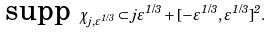<formula> <loc_0><loc_0><loc_500><loc_500>\text {supp } \chi _ { j , \varepsilon ^ { 1 / 3 } } \subset j \varepsilon ^ { 1 / 3 } + [ - \varepsilon ^ { 1 / 3 } , \varepsilon ^ { 1 / 3 } ] ^ { 2 } .</formula> 